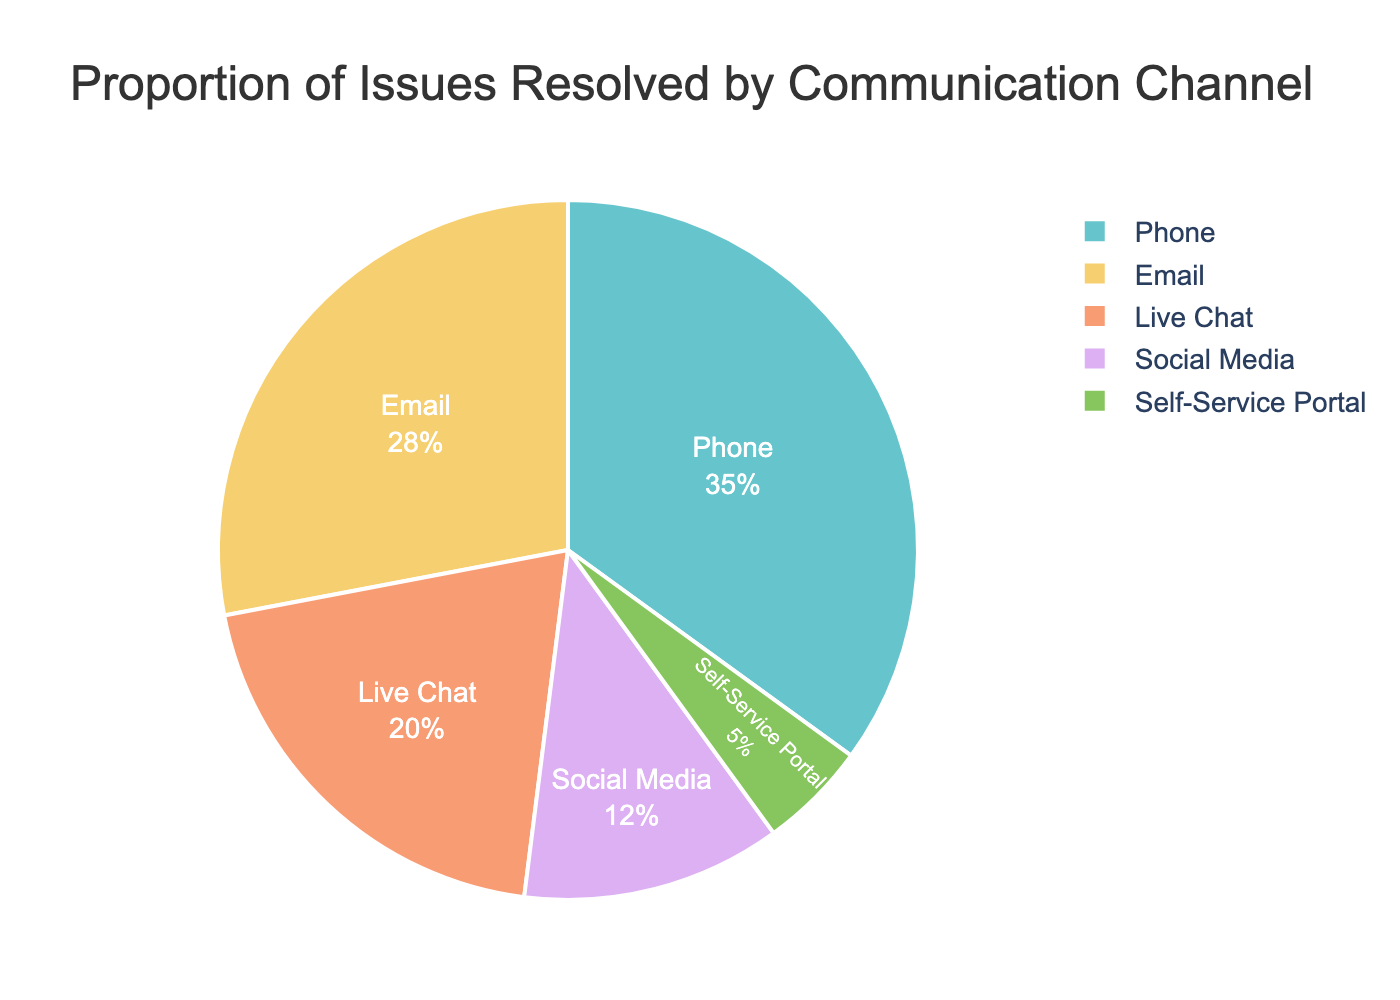What is the proportion of issues resolved through phone calls? Look at the segment labeled "Phone" and refer to the percentage provided within that segment. The chart shows that 35% of issues are resolved through phone calls.
Answer: 35% Which channel resolves the least proportion of issues? Identify the segment with the smallest percentage label. The "Self-Service Portal" segment has the smallest percentage, which is 5%.
Answer: Self-Service Portal How much larger is the proportion of issues resolved via phone compared to live chat? Find the percentages for both phone and live chat, which are 35% and 20%, respectively. Subtract the smaller percentage from the larger one: 35% - 20% = 15%.
Answer: 15% What is the combined percentage of issues resolved through social media and self-service portal? Add the percentages for social media (12%) and self-service portal (5%): 12% + 5% = 17%.
Answer: 17% How many channels have a proportion of resolved issues greater than 20%? Identify the segments with percentages greater than 20%. The channels are Phone (35%) and Email (28%), totaling 2 channels.
Answer: 2 Which communication channel resolves more issues, email or live chat? Compare the percentage labels for Email (28%) and Live Chat (20%). Email has a higher percentage than Live Chat.
Answer: Email Is the proportion of issues resolved through email and live chat exactly half of the total percentage? Add the percentages for email (28%) and live chat (20%): 28% + 20% = 48%. This is not exactly half of the total (100%).
Answer: No Which channel has the largest segment in the pie chart? Identify the segment with the largest percentage label, which is "Phone" at 35%, making it the largest segment.
Answer: Phone Which two channels combined have a higher resolution rate than Phone alone? Check combinations of smaller segments. The combination of Email (28%) and Live Chat (20%) totals 48%, which is higher than Phone's 35%.
Answer: Email and Live Chat 